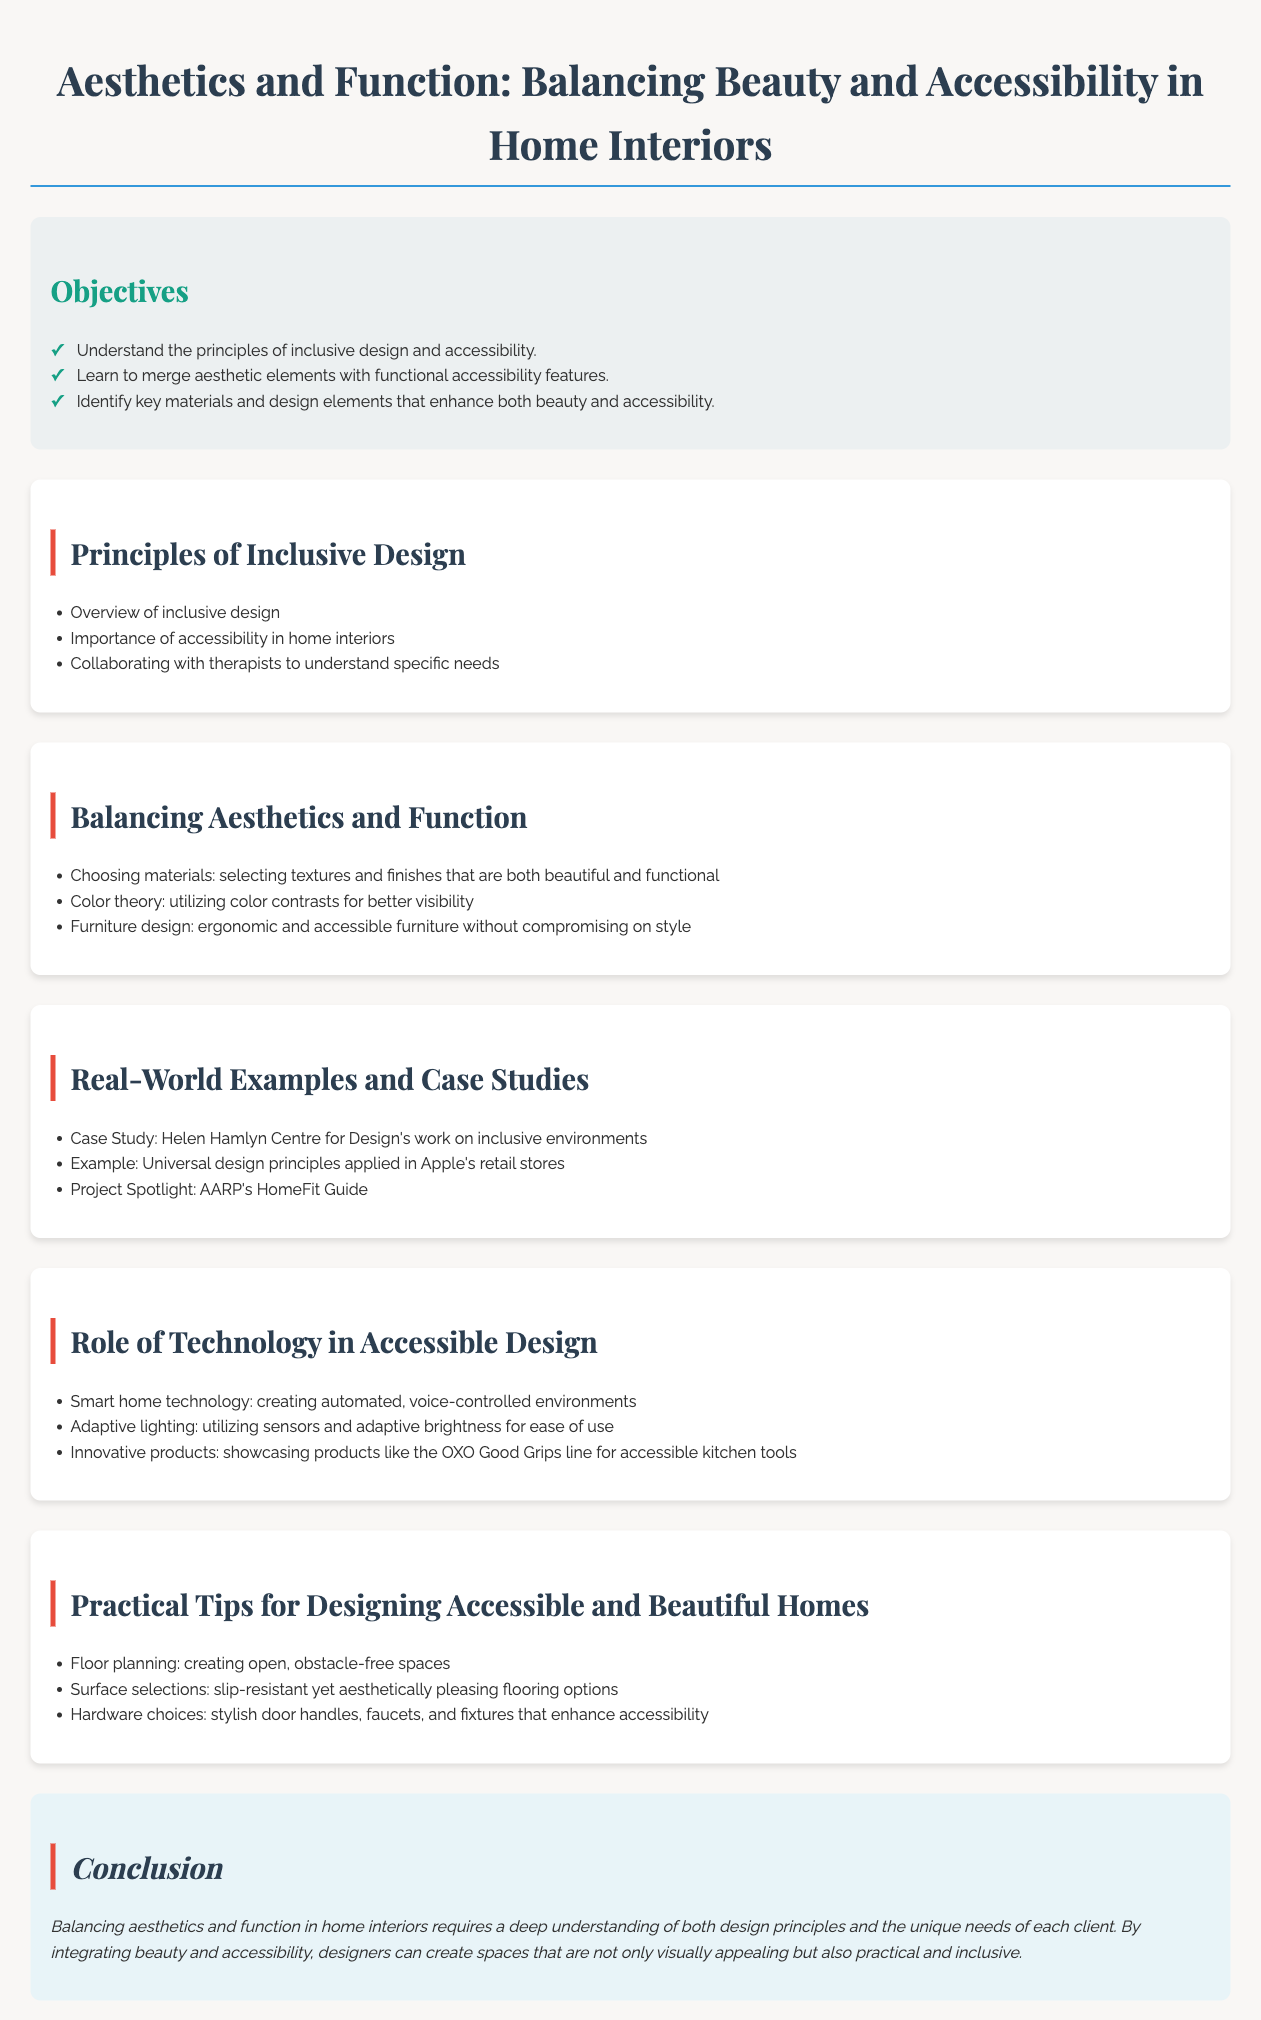What is the title of the lesson plan? The title of the lesson plan is prominently displayed at the top of the document.
Answer: Aesthetics and Function: Balancing Beauty and Accessibility in Home Interiors How many objectives are listed? The document lists three objectives under the objectives section.
Answer: 3 Name one principle of inclusive design mentioned. The document provides an overview of principles in the middle section, which includes key concepts.
Answer: Overview of inclusive design List one example given in the real-world case studies. The case studies section includes three specific examples that show real-world applications.
Answer: Helen Hamlyn Centre for Design's work on inclusive environments What technology is discussed in the section about accessible design? The technology section covers various innovations that assist in creating accessible environments.
Answer: Smart home technology What is one practical tip for designing accessible homes? The practical tips section offers several suggestions aimed at improving accessibility while maintaining aesthetics.
Answer: Floor planning: creating open, obstacle-free spaces Which color aspect is emphasized for visibility? The document highlights the importance of color in terms of enhancing visibility in interior designs.
Answer: Color contrasts What is the background color of the conclusion section? The document provides details about the visual elements, including the background colors used for sections.
Answer: #e8f4f8 